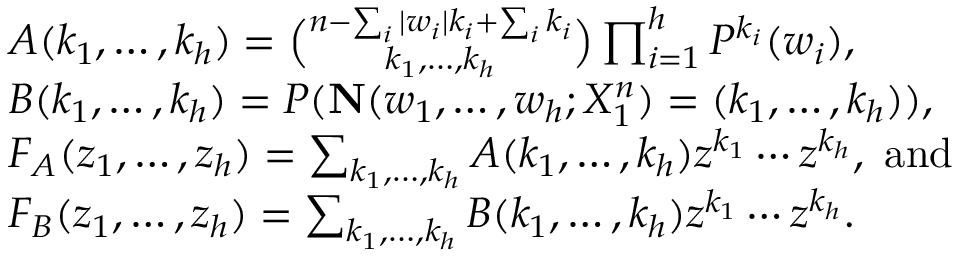<formula> <loc_0><loc_0><loc_500><loc_500>\begin{array} { r l } & { A ( k _ { 1 } , \dots , k _ { h } ) = \binom { n - \sum _ { i } | w _ { i } | k _ { i } + \sum _ { i } k _ { i } } { k _ { 1 } , \dots , k _ { h } } \prod _ { i = 1 } ^ { h } P ^ { k _ { i } } ( w _ { i } ) , } \\ & { B ( k _ { 1 } , \dots , k _ { h } ) = P ( { N } ( w _ { 1 } , \dots , w _ { h } ; X _ { 1 } ^ { n } ) = ( k _ { 1 } , \dots , k _ { h } ) ) , } \\ & { F _ { A } ( z _ { 1 } , \dots , z _ { h } ) = \sum _ { k _ { 1 } , \dots , k _ { h } } A ( k _ { 1 } , \dots , k _ { h } ) z ^ { k _ { 1 } } \cdots z ^ { k _ { h } } , a n d } \\ & { F _ { B } ( z _ { 1 } , \dots , z _ { h } ) = \sum _ { k _ { 1 } , \dots , k _ { h } } B ( k _ { 1 } , \dots , k _ { h } ) z ^ { k _ { 1 } } \cdots z ^ { k _ { h } } . } \end{array}</formula> 